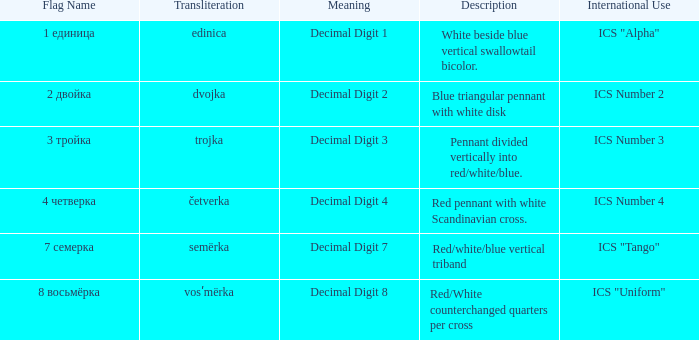What are the various significances of the flag with the name transliterated as semërka? Decimal Digit 7. 